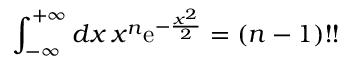<formula> <loc_0><loc_0><loc_500><loc_500>\int _ { - \infty } ^ { + \infty } d x \, x ^ { n } e ^ { - \frac { x ^ { 2 } } { 2 } } = ( n - 1 ) ! !</formula> 